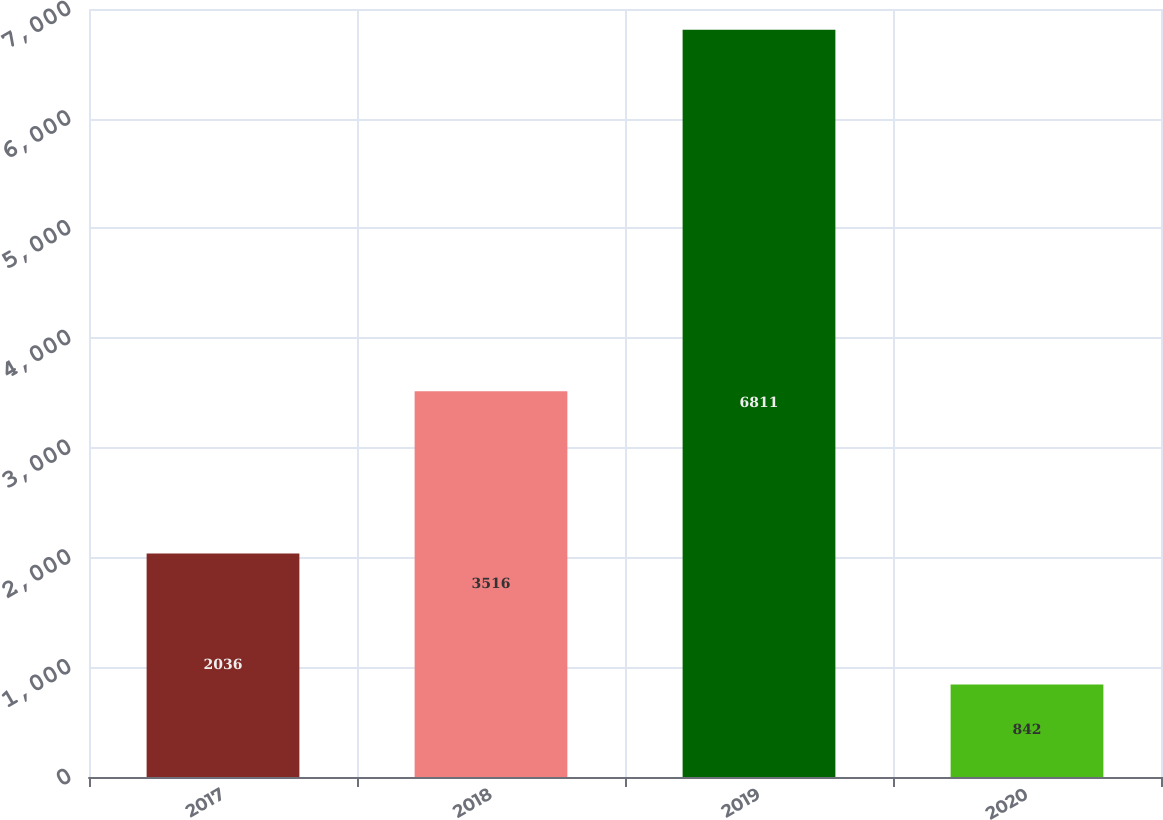<chart> <loc_0><loc_0><loc_500><loc_500><bar_chart><fcel>2017<fcel>2018<fcel>2019<fcel>2020<nl><fcel>2036<fcel>3516<fcel>6811<fcel>842<nl></chart> 